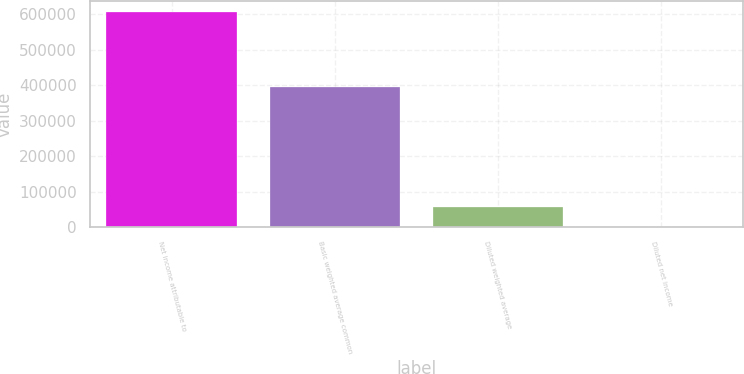Convert chart. <chart><loc_0><loc_0><loc_500><loc_500><bar_chart><fcel>Net income attributable to<fcel>Basic weighted average common<fcel>Diluted weighted average<fcel>Diluted net income<nl><fcel>606466<fcel>395040<fcel>55134.5<fcel>1.38<nl></chart> 